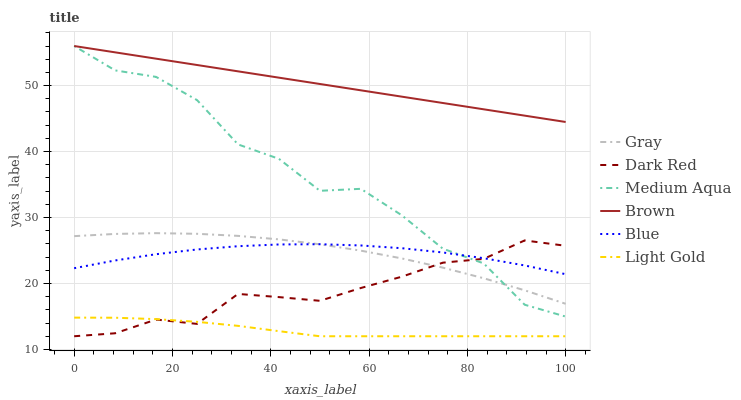Does Gray have the minimum area under the curve?
Answer yes or no. No. Does Gray have the maximum area under the curve?
Answer yes or no. No. Is Gray the smoothest?
Answer yes or no. No. Is Gray the roughest?
Answer yes or no. No. Does Gray have the lowest value?
Answer yes or no. No. Does Gray have the highest value?
Answer yes or no. No. Is Light Gold less than Blue?
Answer yes or no. Yes. Is Medium Aqua greater than Light Gold?
Answer yes or no. Yes. Does Light Gold intersect Blue?
Answer yes or no. No. 